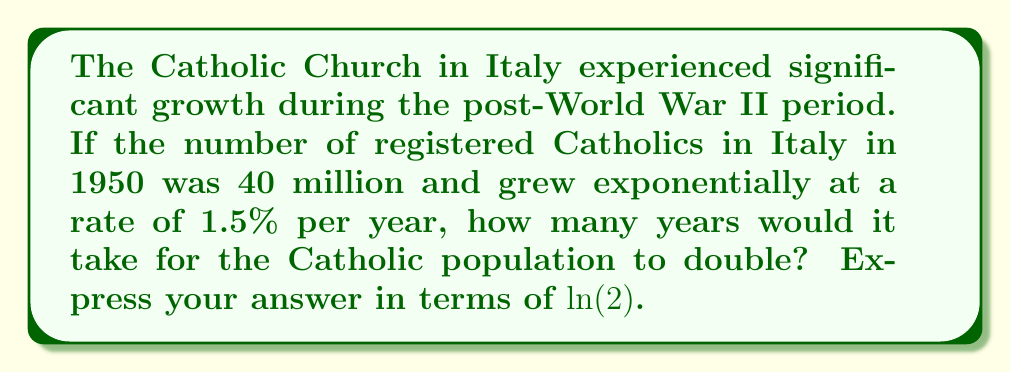Give your solution to this math problem. Let's approach this step-by-step using the exponential growth model and properties of logarithms:

1) The exponential growth model is given by:
   $A(t) = A_0 e^{rt}$
   where $A_0$ is the initial amount, $r$ is the growth rate, and $t$ is time.

2) We want to find $t$ when the population doubles:
   $2A_0 = A_0 e^{rt}$

3) Divide both sides by $A_0$:
   $2 = e^{rt}$

4) Take the natural logarithm of both sides:
   $\ln(2) = \ln(e^{rt})$

5) Using the logarithm property $\ln(e^x) = x$:
   $\ln(2) = rt$

6) Solve for $t$:
   $t = \frac{\ln(2)}{r}$

7) Substitute $r = 0.015$ (1.5% = 0.015):
   $t = \frac{\ln(2)}{0.015}$

8) Simplify:
   $t = \frac{100}{15} \ln(2)$

Therefore, the time for the Catholic population to double is $\frac{100}{15} \ln(2)$ years.
Answer: $\frac{100}{15} \ln(2)$ years 